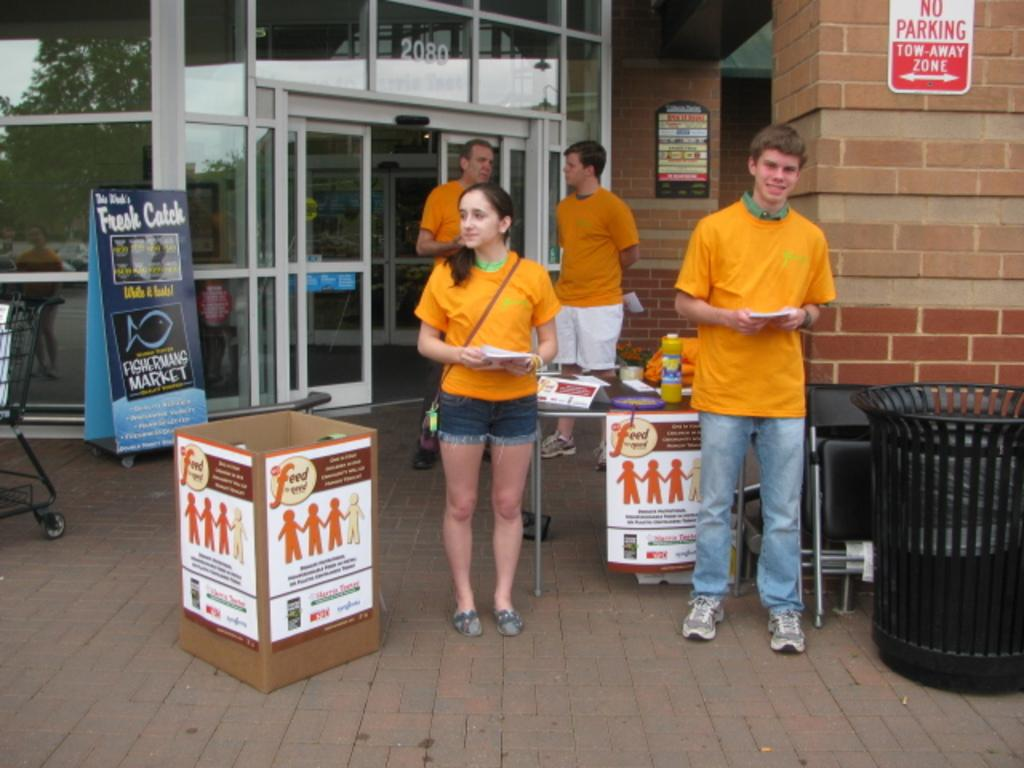<image>
Create a compact narrative representing the image presented. A sign indicates that this area is a no parking tow-away zone. 